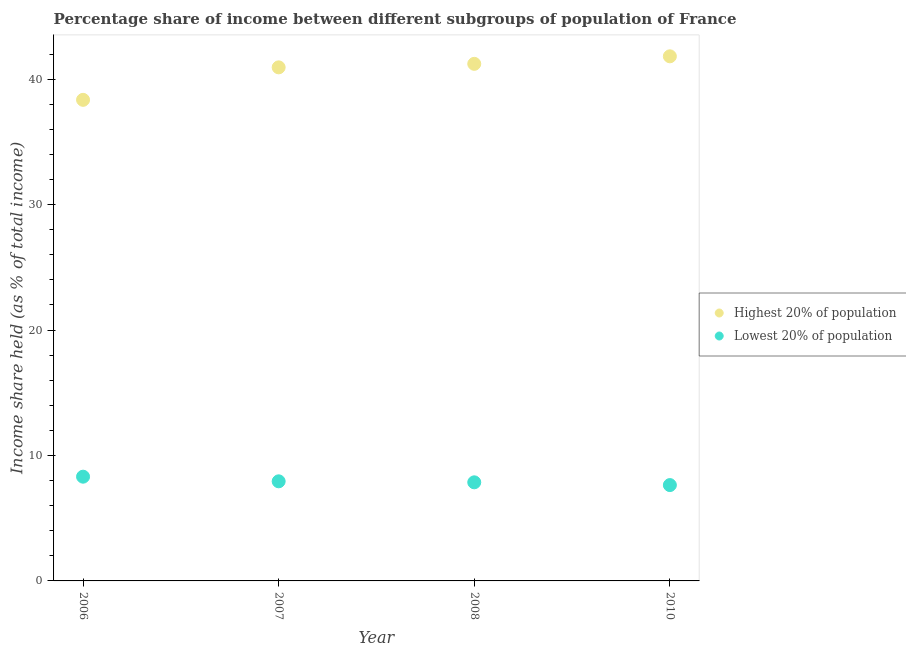How many different coloured dotlines are there?
Give a very brief answer. 2. Is the number of dotlines equal to the number of legend labels?
Your answer should be compact. Yes. What is the income share held by highest 20% of the population in 2007?
Provide a succinct answer. 40.94. Across all years, what is the maximum income share held by lowest 20% of the population?
Your answer should be compact. 8.31. Across all years, what is the minimum income share held by lowest 20% of the population?
Your answer should be very brief. 7.64. In which year was the income share held by highest 20% of the population maximum?
Give a very brief answer. 2010. What is the total income share held by highest 20% of the population in the graph?
Offer a very short reply. 162.33. What is the difference between the income share held by lowest 20% of the population in 2007 and that in 2008?
Keep it short and to the point. 0.08. What is the difference between the income share held by highest 20% of the population in 2007 and the income share held by lowest 20% of the population in 2008?
Offer a very short reply. 33.08. What is the average income share held by lowest 20% of the population per year?
Your answer should be compact. 7.94. In the year 2008, what is the difference between the income share held by highest 20% of the population and income share held by lowest 20% of the population?
Provide a short and direct response. 33.36. What is the ratio of the income share held by lowest 20% of the population in 2008 to that in 2010?
Keep it short and to the point. 1.03. What is the difference between the highest and the second highest income share held by highest 20% of the population?
Your answer should be compact. 0.6. What is the difference between the highest and the lowest income share held by highest 20% of the population?
Your response must be concise. 3.47. Does the income share held by highest 20% of the population monotonically increase over the years?
Offer a very short reply. Yes. How many years are there in the graph?
Give a very brief answer. 4. Does the graph contain any zero values?
Give a very brief answer. No. Does the graph contain grids?
Offer a very short reply. No. How many legend labels are there?
Your answer should be very brief. 2. What is the title of the graph?
Your answer should be compact. Percentage share of income between different subgroups of population of France. Does "GDP per capita" appear as one of the legend labels in the graph?
Give a very brief answer. No. What is the label or title of the Y-axis?
Your response must be concise. Income share held (as % of total income). What is the Income share held (as % of total income) in Highest 20% of population in 2006?
Make the answer very short. 38.35. What is the Income share held (as % of total income) of Lowest 20% of population in 2006?
Provide a succinct answer. 8.31. What is the Income share held (as % of total income) of Highest 20% of population in 2007?
Your answer should be compact. 40.94. What is the Income share held (as % of total income) of Lowest 20% of population in 2007?
Ensure brevity in your answer.  7.94. What is the Income share held (as % of total income) in Highest 20% of population in 2008?
Offer a terse response. 41.22. What is the Income share held (as % of total income) in Lowest 20% of population in 2008?
Your response must be concise. 7.86. What is the Income share held (as % of total income) of Highest 20% of population in 2010?
Offer a terse response. 41.82. What is the Income share held (as % of total income) of Lowest 20% of population in 2010?
Provide a succinct answer. 7.64. Across all years, what is the maximum Income share held (as % of total income) of Highest 20% of population?
Your response must be concise. 41.82. Across all years, what is the maximum Income share held (as % of total income) of Lowest 20% of population?
Provide a succinct answer. 8.31. Across all years, what is the minimum Income share held (as % of total income) of Highest 20% of population?
Provide a succinct answer. 38.35. Across all years, what is the minimum Income share held (as % of total income) of Lowest 20% of population?
Offer a very short reply. 7.64. What is the total Income share held (as % of total income) in Highest 20% of population in the graph?
Your answer should be very brief. 162.33. What is the total Income share held (as % of total income) of Lowest 20% of population in the graph?
Give a very brief answer. 31.75. What is the difference between the Income share held (as % of total income) of Highest 20% of population in 2006 and that in 2007?
Provide a succinct answer. -2.59. What is the difference between the Income share held (as % of total income) in Lowest 20% of population in 2006 and that in 2007?
Offer a very short reply. 0.37. What is the difference between the Income share held (as % of total income) in Highest 20% of population in 2006 and that in 2008?
Keep it short and to the point. -2.87. What is the difference between the Income share held (as % of total income) of Lowest 20% of population in 2006 and that in 2008?
Provide a short and direct response. 0.45. What is the difference between the Income share held (as % of total income) in Highest 20% of population in 2006 and that in 2010?
Your answer should be compact. -3.47. What is the difference between the Income share held (as % of total income) in Lowest 20% of population in 2006 and that in 2010?
Offer a very short reply. 0.67. What is the difference between the Income share held (as % of total income) in Highest 20% of population in 2007 and that in 2008?
Provide a succinct answer. -0.28. What is the difference between the Income share held (as % of total income) in Lowest 20% of population in 2007 and that in 2008?
Your answer should be compact. 0.08. What is the difference between the Income share held (as % of total income) of Highest 20% of population in 2007 and that in 2010?
Give a very brief answer. -0.88. What is the difference between the Income share held (as % of total income) of Highest 20% of population in 2008 and that in 2010?
Your answer should be very brief. -0.6. What is the difference between the Income share held (as % of total income) in Lowest 20% of population in 2008 and that in 2010?
Make the answer very short. 0.22. What is the difference between the Income share held (as % of total income) of Highest 20% of population in 2006 and the Income share held (as % of total income) of Lowest 20% of population in 2007?
Your answer should be very brief. 30.41. What is the difference between the Income share held (as % of total income) of Highest 20% of population in 2006 and the Income share held (as % of total income) of Lowest 20% of population in 2008?
Provide a short and direct response. 30.49. What is the difference between the Income share held (as % of total income) of Highest 20% of population in 2006 and the Income share held (as % of total income) of Lowest 20% of population in 2010?
Ensure brevity in your answer.  30.71. What is the difference between the Income share held (as % of total income) of Highest 20% of population in 2007 and the Income share held (as % of total income) of Lowest 20% of population in 2008?
Offer a terse response. 33.08. What is the difference between the Income share held (as % of total income) in Highest 20% of population in 2007 and the Income share held (as % of total income) in Lowest 20% of population in 2010?
Your answer should be very brief. 33.3. What is the difference between the Income share held (as % of total income) in Highest 20% of population in 2008 and the Income share held (as % of total income) in Lowest 20% of population in 2010?
Ensure brevity in your answer.  33.58. What is the average Income share held (as % of total income) of Highest 20% of population per year?
Keep it short and to the point. 40.58. What is the average Income share held (as % of total income) in Lowest 20% of population per year?
Provide a short and direct response. 7.94. In the year 2006, what is the difference between the Income share held (as % of total income) of Highest 20% of population and Income share held (as % of total income) of Lowest 20% of population?
Your response must be concise. 30.04. In the year 2008, what is the difference between the Income share held (as % of total income) in Highest 20% of population and Income share held (as % of total income) in Lowest 20% of population?
Your answer should be compact. 33.36. In the year 2010, what is the difference between the Income share held (as % of total income) in Highest 20% of population and Income share held (as % of total income) in Lowest 20% of population?
Your answer should be compact. 34.18. What is the ratio of the Income share held (as % of total income) in Highest 20% of population in 2006 to that in 2007?
Keep it short and to the point. 0.94. What is the ratio of the Income share held (as % of total income) in Lowest 20% of population in 2006 to that in 2007?
Ensure brevity in your answer.  1.05. What is the ratio of the Income share held (as % of total income) of Highest 20% of population in 2006 to that in 2008?
Your answer should be compact. 0.93. What is the ratio of the Income share held (as % of total income) of Lowest 20% of population in 2006 to that in 2008?
Offer a terse response. 1.06. What is the ratio of the Income share held (as % of total income) in Highest 20% of population in 2006 to that in 2010?
Offer a terse response. 0.92. What is the ratio of the Income share held (as % of total income) of Lowest 20% of population in 2006 to that in 2010?
Make the answer very short. 1.09. What is the ratio of the Income share held (as % of total income) in Highest 20% of population in 2007 to that in 2008?
Make the answer very short. 0.99. What is the ratio of the Income share held (as % of total income) in Lowest 20% of population in 2007 to that in 2008?
Give a very brief answer. 1.01. What is the ratio of the Income share held (as % of total income) in Lowest 20% of population in 2007 to that in 2010?
Provide a succinct answer. 1.04. What is the ratio of the Income share held (as % of total income) of Highest 20% of population in 2008 to that in 2010?
Your response must be concise. 0.99. What is the ratio of the Income share held (as % of total income) in Lowest 20% of population in 2008 to that in 2010?
Provide a succinct answer. 1.03. What is the difference between the highest and the second highest Income share held (as % of total income) in Lowest 20% of population?
Ensure brevity in your answer.  0.37. What is the difference between the highest and the lowest Income share held (as % of total income) of Highest 20% of population?
Provide a short and direct response. 3.47. What is the difference between the highest and the lowest Income share held (as % of total income) in Lowest 20% of population?
Offer a terse response. 0.67. 